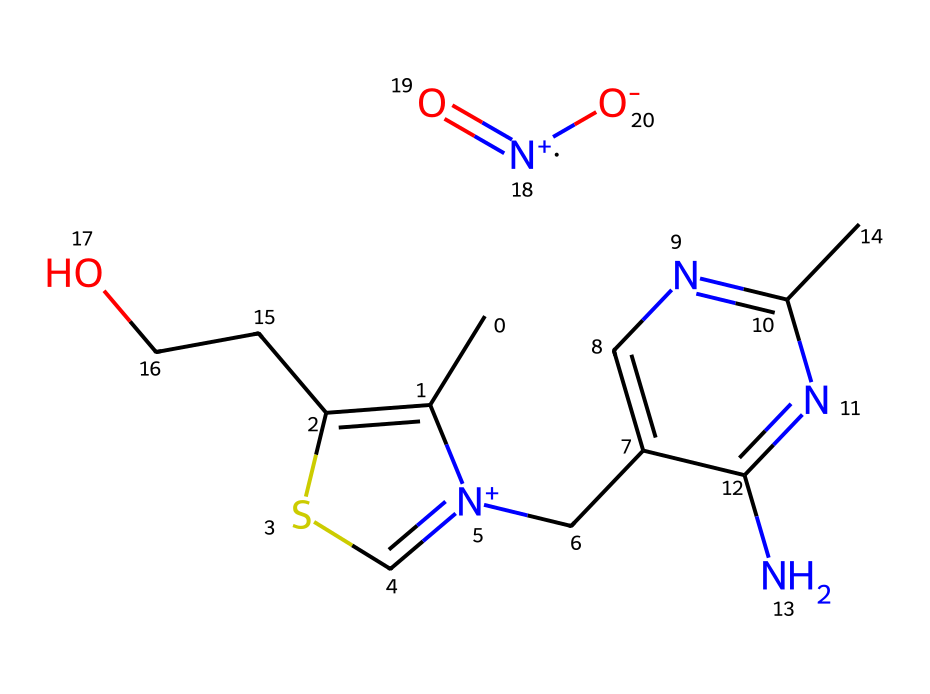How many carbon atoms are in the chemical structure? By examining the SMILES representation, we can count the carbon atoms indicated by 'C'. The chain shows several 'C's, and after counting them, we find that there are a total of 9 carbon atoms present in the structure.
Answer: 9 What functional groups are present in thiamine mononitrate? In the chemical structure, we can identify a hydroxyl group (-OH) indicated by 'CCO' and a nitro group (-NO2) indicated by '[N+](=O)[O-]'. These suggest the presence of alcohol and nitrates as functional groups in thiamine mononitrate.
Answer: alcohol and nitrate What is the total number of nitrogen atoms in the structure? The SMILES representation includes nitrogen atoms indicated by 'N'. Upon counting, we see there are 4 nitrogen atoms present in the entire structure.
Answer: 4 Which part of the molecule indicates it belongs to the nitrile group? In the structure, the nitrogen atom bonded to a carbon with a triple bond appears as 'C#N' in chemical representations. However, in this specific structure, the nitrile feature is not visibly prominent; we are identifying it as being structural derivative related to nitrogens. Typically for a nitrile, there would be a clear representation of this functional group. Overall, the complex structure does not explicitly denote nitrile but involves nitrogen functionalities.
Answer: Not explicitly present What type of bond connects the nitrogen to the carbon structure? By analyzing the structure, we see that the nitrogen is primarily connected through single or double bonds as part of a ring structure or through chains. The nitrogen atoms in this chemical are part of amine groups, which use single bonds to connect to carbon atoms in this context.
Answer: single or double bond 